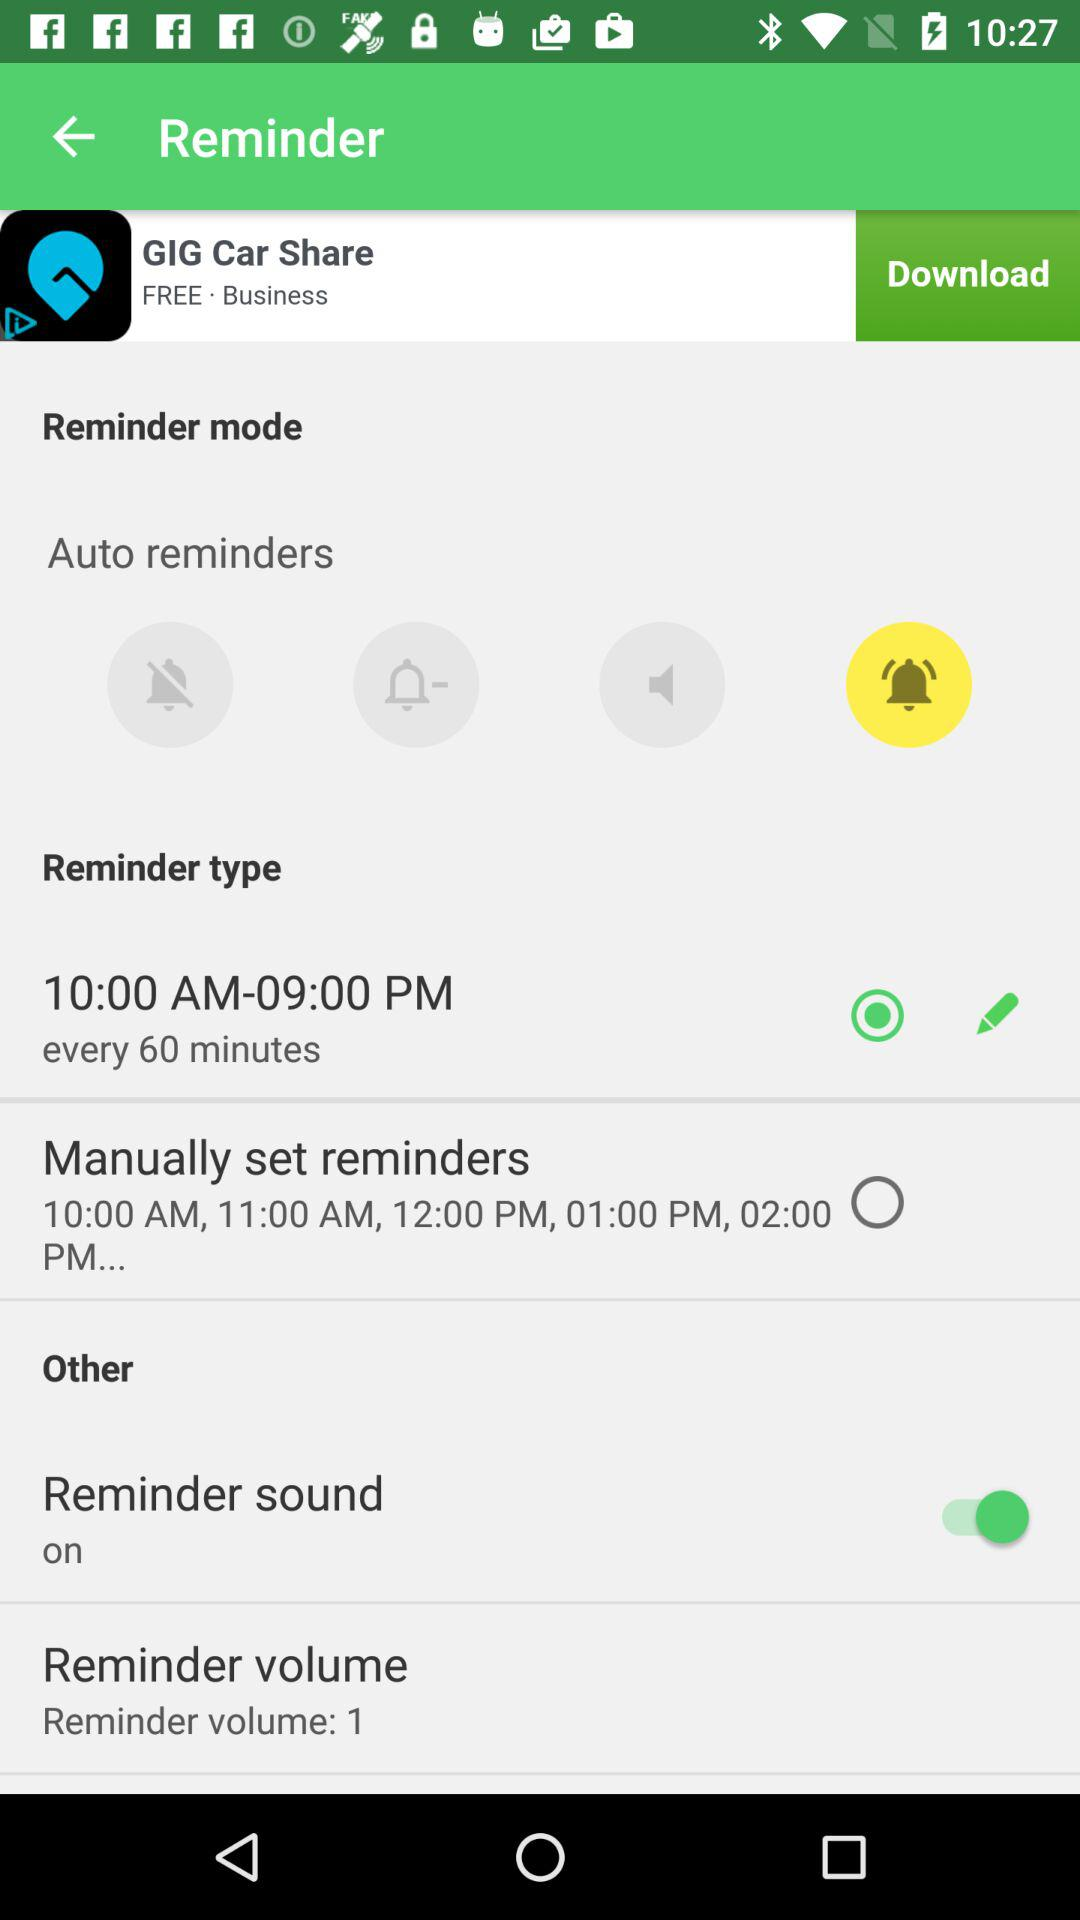What is the selected level of reminder volume? The selected level of reminder volume is 1. 